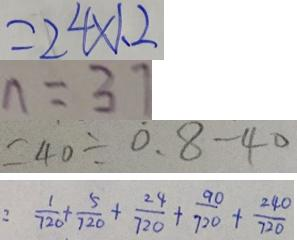<formula> <loc_0><loc_0><loc_500><loc_500>= 2 4 \times 1 . 2 
 n = 3 7 
 = 4 0 \div 0 . 8 - 4 0 
 : \frac { 1 } { 7 2 0 } + \frac { 5 } { 7 2 0 } + \frac { 2 4 } { 7 2 0 } + \frac { 9 0 } { 7 2 0 } + \frac { 2 4 0 } { 7 2 0 }</formula> 